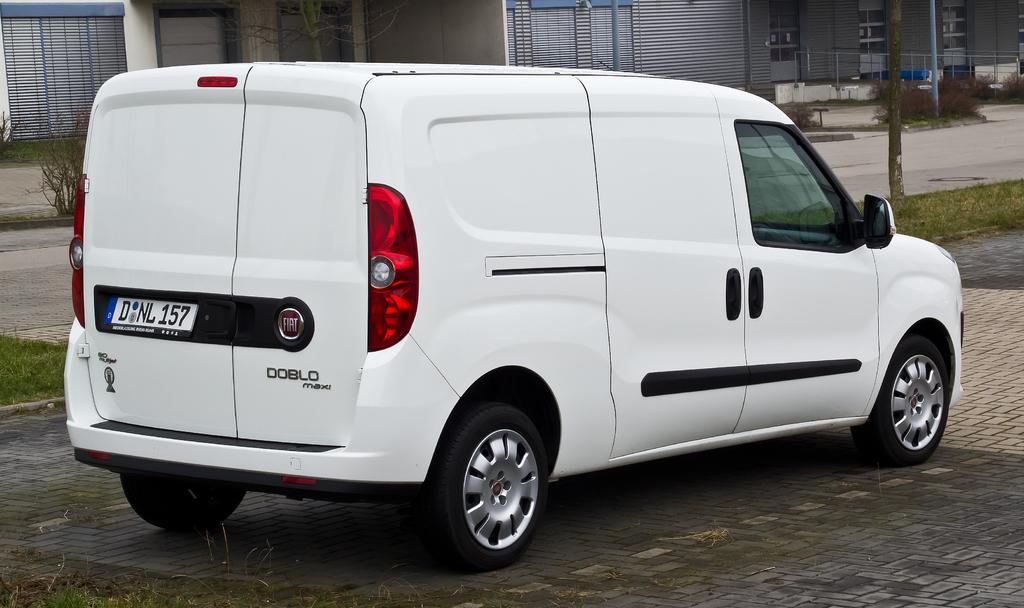Can you describe this image briefly? In the image there is a car. Behind the car there's grass on the ground. And also there are walls with glass doors and also there is railing. 